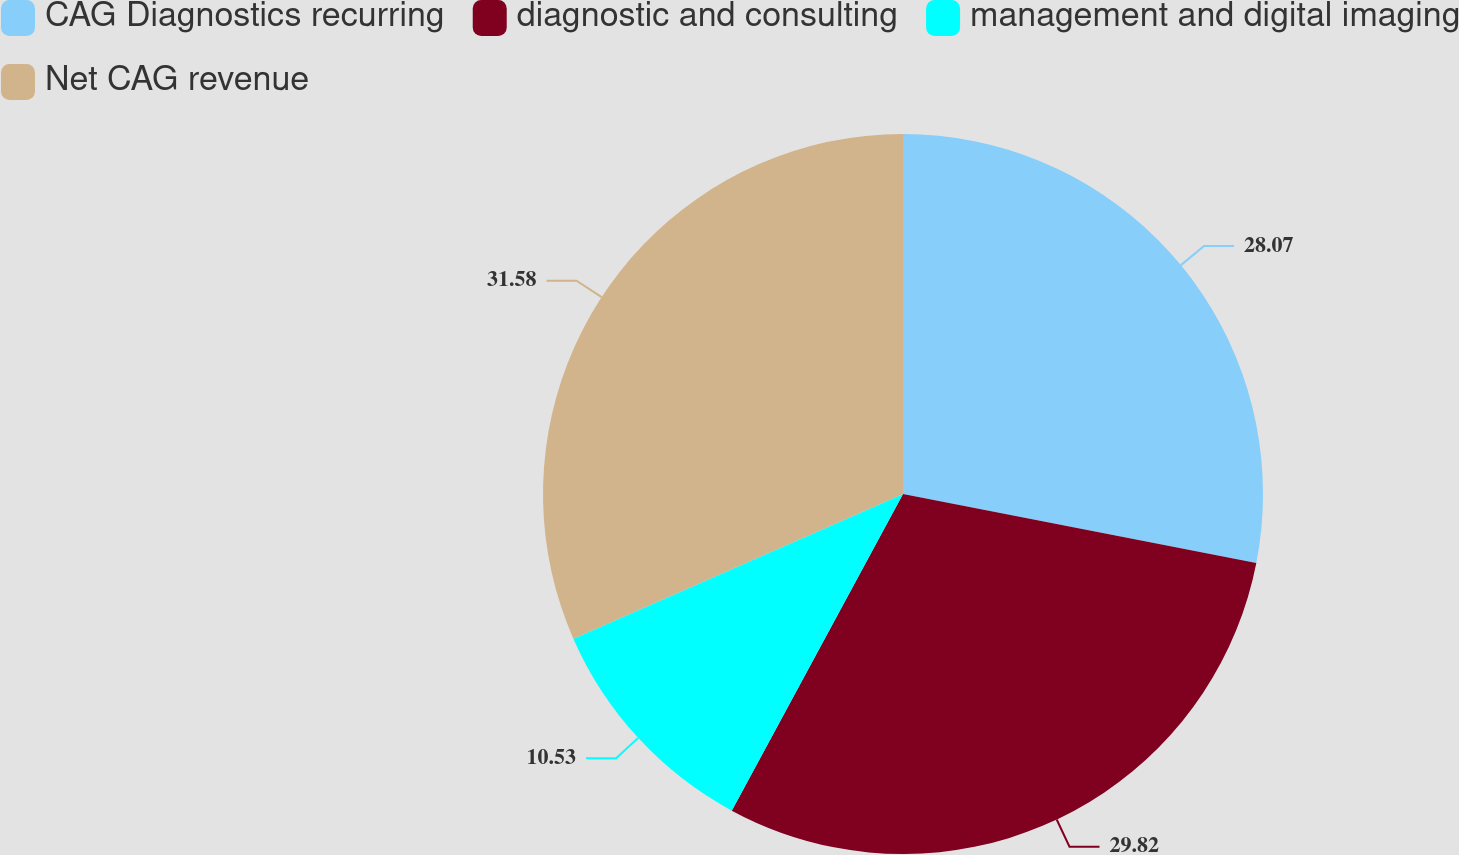Convert chart. <chart><loc_0><loc_0><loc_500><loc_500><pie_chart><fcel>CAG Diagnostics recurring<fcel>diagnostic and consulting<fcel>management and digital imaging<fcel>Net CAG revenue<nl><fcel>28.07%<fcel>29.82%<fcel>10.53%<fcel>31.58%<nl></chart> 